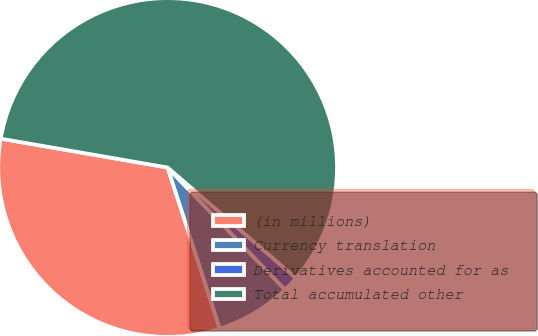Convert chart to OTSL. <chart><loc_0><loc_0><loc_500><loc_500><pie_chart><fcel>(in millions)<fcel>Currency translation<fcel>Derivatives accounted for as<fcel>Total accumulated other<nl><fcel>32.71%<fcel>7.21%<fcel>1.5%<fcel>58.59%<nl></chart> 